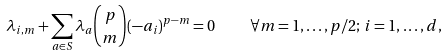Convert formula to latex. <formula><loc_0><loc_0><loc_500><loc_500>\lambda _ { i , m } + \sum _ { a \in S } \lambda _ { a } \binom { p } { m } ( - a _ { i } ) ^ { p - m } = 0 \quad \forall m = 1 , \dots , p / 2 ; \, i = 1 , \dots , d ,</formula> 